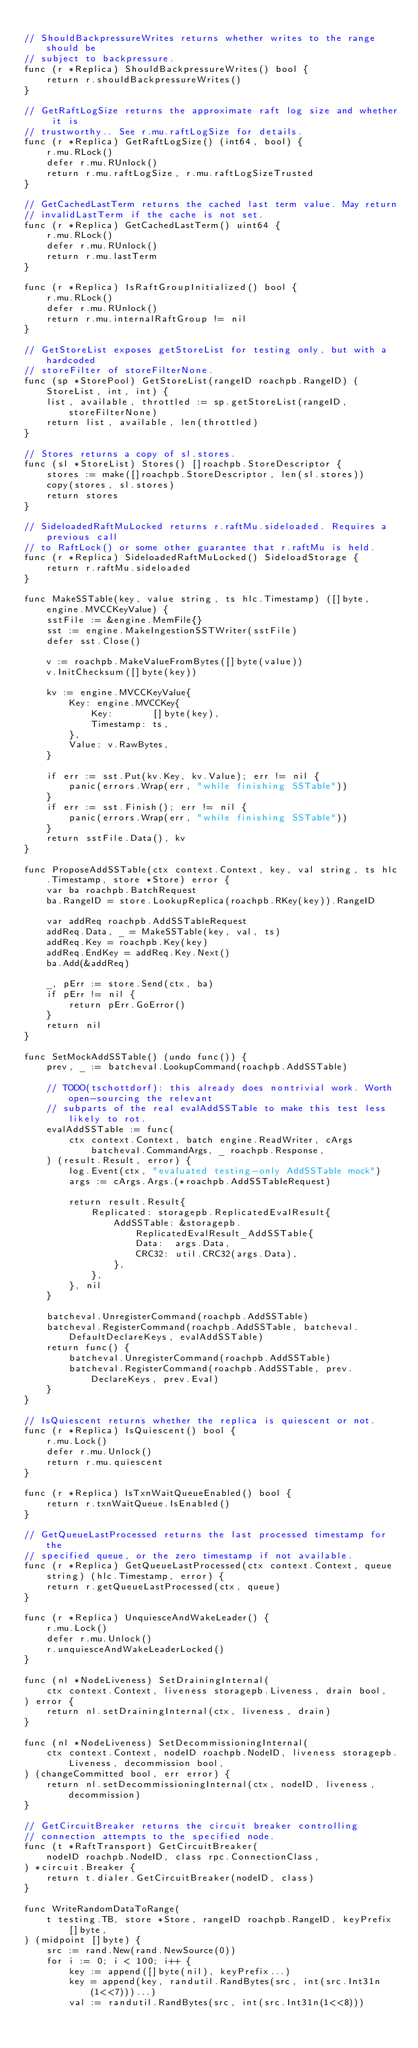<code> <loc_0><loc_0><loc_500><loc_500><_Go_>
// ShouldBackpressureWrites returns whether writes to the range should be
// subject to backpressure.
func (r *Replica) ShouldBackpressureWrites() bool {
	return r.shouldBackpressureWrites()
}

// GetRaftLogSize returns the approximate raft log size and whether it is
// trustworthy.. See r.mu.raftLogSize for details.
func (r *Replica) GetRaftLogSize() (int64, bool) {
	r.mu.RLock()
	defer r.mu.RUnlock()
	return r.mu.raftLogSize, r.mu.raftLogSizeTrusted
}

// GetCachedLastTerm returns the cached last term value. May return
// invalidLastTerm if the cache is not set.
func (r *Replica) GetCachedLastTerm() uint64 {
	r.mu.RLock()
	defer r.mu.RUnlock()
	return r.mu.lastTerm
}

func (r *Replica) IsRaftGroupInitialized() bool {
	r.mu.RLock()
	defer r.mu.RUnlock()
	return r.mu.internalRaftGroup != nil
}

// GetStoreList exposes getStoreList for testing only, but with a hardcoded
// storeFilter of storeFilterNone.
func (sp *StorePool) GetStoreList(rangeID roachpb.RangeID) (StoreList, int, int) {
	list, available, throttled := sp.getStoreList(rangeID, storeFilterNone)
	return list, available, len(throttled)
}

// Stores returns a copy of sl.stores.
func (sl *StoreList) Stores() []roachpb.StoreDescriptor {
	stores := make([]roachpb.StoreDescriptor, len(sl.stores))
	copy(stores, sl.stores)
	return stores
}

// SideloadedRaftMuLocked returns r.raftMu.sideloaded. Requires a previous call
// to RaftLock() or some other guarantee that r.raftMu is held.
func (r *Replica) SideloadedRaftMuLocked() SideloadStorage {
	return r.raftMu.sideloaded
}

func MakeSSTable(key, value string, ts hlc.Timestamp) ([]byte, engine.MVCCKeyValue) {
	sstFile := &engine.MemFile{}
	sst := engine.MakeIngestionSSTWriter(sstFile)
	defer sst.Close()

	v := roachpb.MakeValueFromBytes([]byte(value))
	v.InitChecksum([]byte(key))

	kv := engine.MVCCKeyValue{
		Key: engine.MVCCKey{
			Key:       []byte(key),
			Timestamp: ts,
		},
		Value: v.RawBytes,
	}

	if err := sst.Put(kv.Key, kv.Value); err != nil {
		panic(errors.Wrap(err, "while finishing SSTable"))
	}
	if err := sst.Finish(); err != nil {
		panic(errors.Wrap(err, "while finishing SSTable"))
	}
	return sstFile.Data(), kv
}

func ProposeAddSSTable(ctx context.Context, key, val string, ts hlc.Timestamp, store *Store) error {
	var ba roachpb.BatchRequest
	ba.RangeID = store.LookupReplica(roachpb.RKey(key)).RangeID

	var addReq roachpb.AddSSTableRequest
	addReq.Data, _ = MakeSSTable(key, val, ts)
	addReq.Key = roachpb.Key(key)
	addReq.EndKey = addReq.Key.Next()
	ba.Add(&addReq)

	_, pErr := store.Send(ctx, ba)
	if pErr != nil {
		return pErr.GoError()
	}
	return nil
}

func SetMockAddSSTable() (undo func()) {
	prev, _ := batcheval.LookupCommand(roachpb.AddSSTable)

	// TODO(tschottdorf): this already does nontrivial work. Worth open-sourcing the relevant
	// subparts of the real evalAddSSTable to make this test less likely to rot.
	evalAddSSTable := func(
		ctx context.Context, batch engine.ReadWriter, cArgs batcheval.CommandArgs, _ roachpb.Response,
	) (result.Result, error) {
		log.Event(ctx, "evaluated testing-only AddSSTable mock")
		args := cArgs.Args.(*roachpb.AddSSTableRequest)

		return result.Result{
			Replicated: storagepb.ReplicatedEvalResult{
				AddSSTable: &storagepb.ReplicatedEvalResult_AddSSTable{
					Data:  args.Data,
					CRC32: util.CRC32(args.Data),
				},
			},
		}, nil
	}

	batcheval.UnregisterCommand(roachpb.AddSSTable)
	batcheval.RegisterCommand(roachpb.AddSSTable, batcheval.DefaultDeclareKeys, evalAddSSTable)
	return func() {
		batcheval.UnregisterCommand(roachpb.AddSSTable)
		batcheval.RegisterCommand(roachpb.AddSSTable, prev.DeclareKeys, prev.Eval)
	}
}

// IsQuiescent returns whether the replica is quiescent or not.
func (r *Replica) IsQuiescent() bool {
	r.mu.Lock()
	defer r.mu.Unlock()
	return r.mu.quiescent
}

func (r *Replica) IsTxnWaitQueueEnabled() bool {
	return r.txnWaitQueue.IsEnabled()
}

// GetQueueLastProcessed returns the last processed timestamp for the
// specified queue, or the zero timestamp if not available.
func (r *Replica) GetQueueLastProcessed(ctx context.Context, queue string) (hlc.Timestamp, error) {
	return r.getQueueLastProcessed(ctx, queue)
}

func (r *Replica) UnquiesceAndWakeLeader() {
	r.mu.Lock()
	defer r.mu.Unlock()
	r.unquiesceAndWakeLeaderLocked()
}

func (nl *NodeLiveness) SetDrainingInternal(
	ctx context.Context, liveness storagepb.Liveness, drain bool,
) error {
	return nl.setDrainingInternal(ctx, liveness, drain)
}

func (nl *NodeLiveness) SetDecommissioningInternal(
	ctx context.Context, nodeID roachpb.NodeID, liveness storagepb.Liveness, decommission bool,
) (changeCommitted bool, err error) {
	return nl.setDecommissioningInternal(ctx, nodeID, liveness, decommission)
}

// GetCircuitBreaker returns the circuit breaker controlling
// connection attempts to the specified node.
func (t *RaftTransport) GetCircuitBreaker(
	nodeID roachpb.NodeID, class rpc.ConnectionClass,
) *circuit.Breaker {
	return t.dialer.GetCircuitBreaker(nodeID, class)
}

func WriteRandomDataToRange(
	t testing.TB, store *Store, rangeID roachpb.RangeID, keyPrefix []byte,
) (midpoint []byte) {
	src := rand.New(rand.NewSource(0))
	for i := 0; i < 100; i++ {
		key := append([]byte(nil), keyPrefix...)
		key = append(key, randutil.RandBytes(src, int(src.Int31n(1<<7)))...)
		val := randutil.RandBytes(src, int(src.Int31n(1<<8)))</code> 